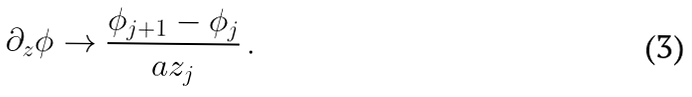Convert formula to latex. <formula><loc_0><loc_0><loc_500><loc_500>\partial _ { z } \phi \to \frac { \phi _ { j + 1 } - \phi _ { j } } { a z _ { j } } \, .</formula> 